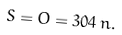<formula> <loc_0><loc_0><loc_500><loc_500>S = O = 3 0 4 \, n .</formula> 